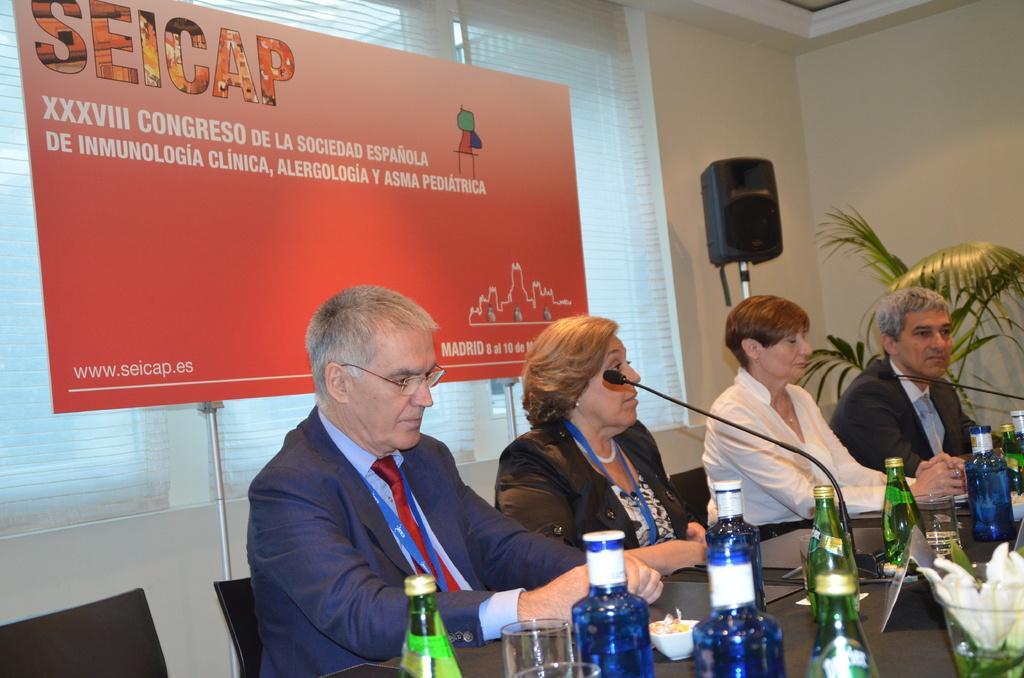Can you describe this image briefly? In the picture we can see four people are sitting on the chairs, two are men and two are women and near them, we can see a desk with some bottles, glasses, and microphones and behind them, we can see a wall with a window and curtain to it and to it we can see a banner with some advertisement on it and besides it we can see a sound box top to the stand and near it we can see some plant. 